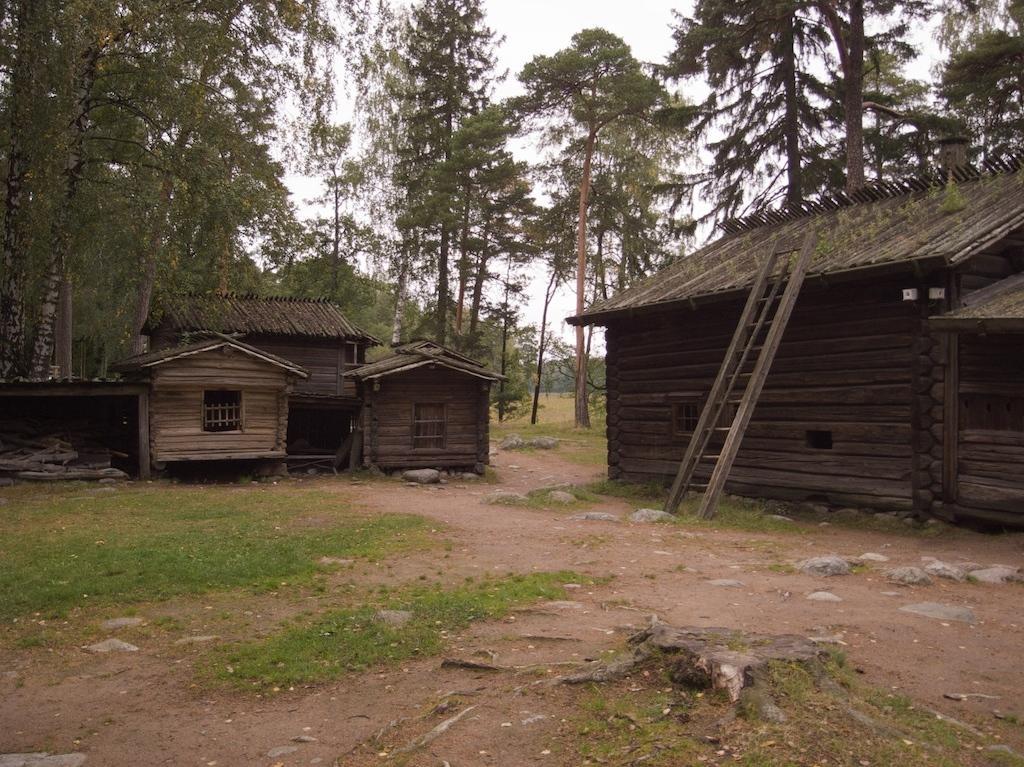Please provide a concise description of this image. In this picture there are few wooden huts and there are trees in the background. 